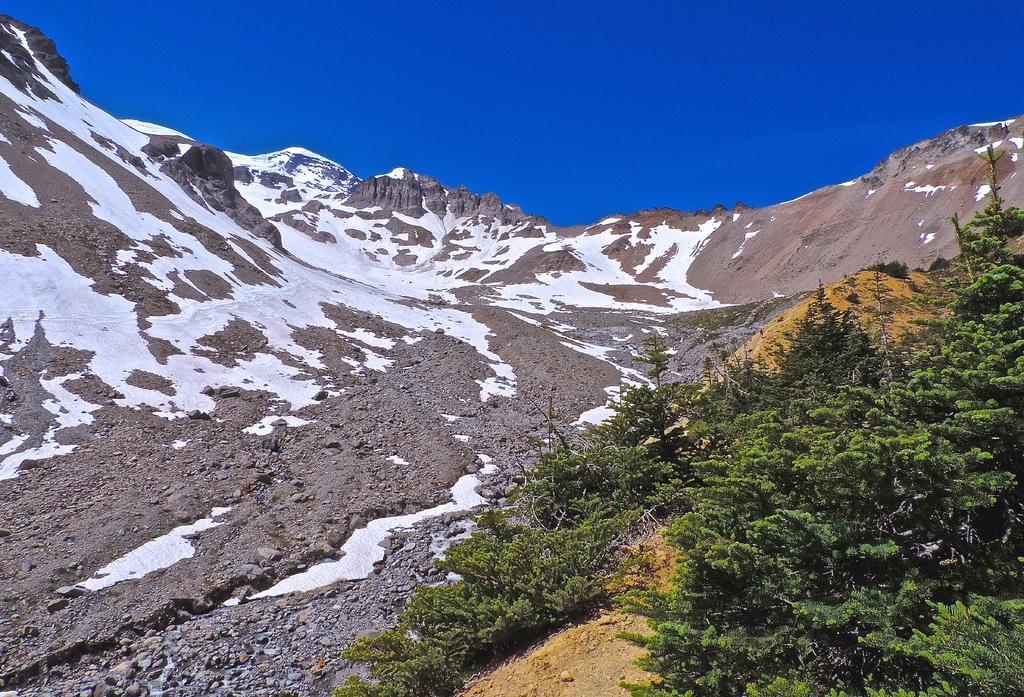Could you give a brief overview of what you see in this image? In this image I can see few mountains, snow and few trees and the sky is in blue color. 